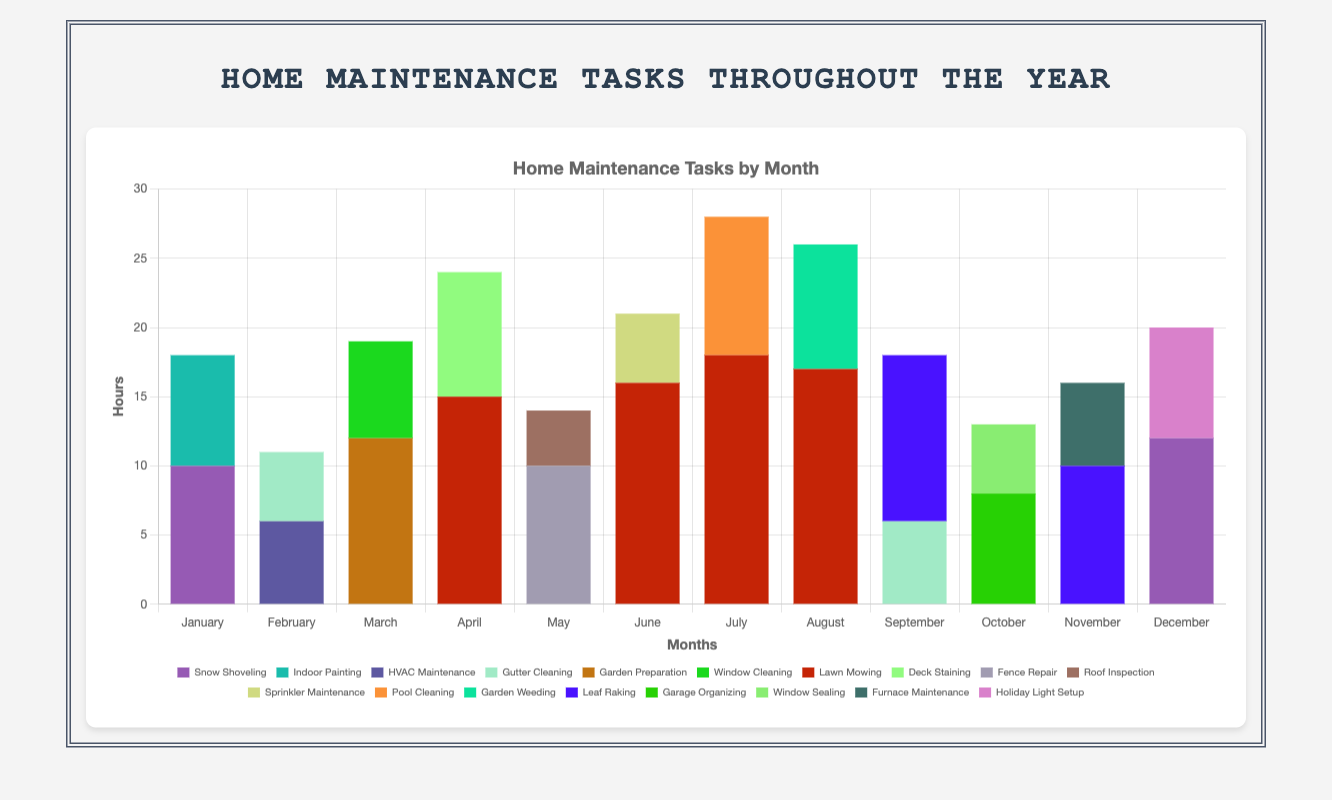How many hours were spent on Lawn Mowing throughout the year? Add up the hours spent on Lawn Mowing in April, June, July, and August. The total is 15 (April) + 16 (June) + 18 (July) + 17 (August) = 66 hours.
Answer: 66 Which month had the highest total hours spent on home maintenance tasks? Compare the total hours for each month. The months with notable totals are July (18 + 10 = 28), and April (15 + 9 = 24). July has the highest total with 28 hours.
Answer: July In which month was the least amount of time spent on home maintenance tasks? Identify the month with the lowest total hours. November has 6 (Furnace Maintenance) + 10 (Leaf Raking) = 16 hours, which is the least.
Answer: November Which maintenance task has the highest total hours in a single month, and how many hours? Check which task in its peak month has the highest hours. Lawn Mowing in July with 18 hours is the highest.
Answer: Lawn Mowing, 18 What is the total number of hours spent on tasks in December? Add the hours in December: Holiday Light Setup (8) and Snow Shoveling (12). The total is 8 + 12 = 20 hours.
Answer: 20 How many months was Lawn Mowing performed? Count the months with Lawn Mowing tasks: April, June, July, and August. This totals to 4 months.
Answer: 4 Which months had Snow Shoveling performed? According to the data, Snow Shoveling was done in January and December.
Answer: January and December What is the average time spent monthly on Leaf Raking? Leaf Raking was performed in September (12 hours) and November (10 hours). Average is (12 + 10) / 2 = 11 hours.
Answer: 11 Compare the total hours spent on HVAC Maintenance and Window Cleaning throughout the year. HVAC Maintenance was done in February (6 hours), and Window Cleaning was done in March (7 hours). HVAC Maintenance = 6, Window Cleaning = 7. Window Cleaning has more hours.
Answer: Window Cleaning In which months were indoor painting tasks performed and how many total hours were spent on it? Indoor Painting was performed only in January with 8 hours.
Answer: January, 8 